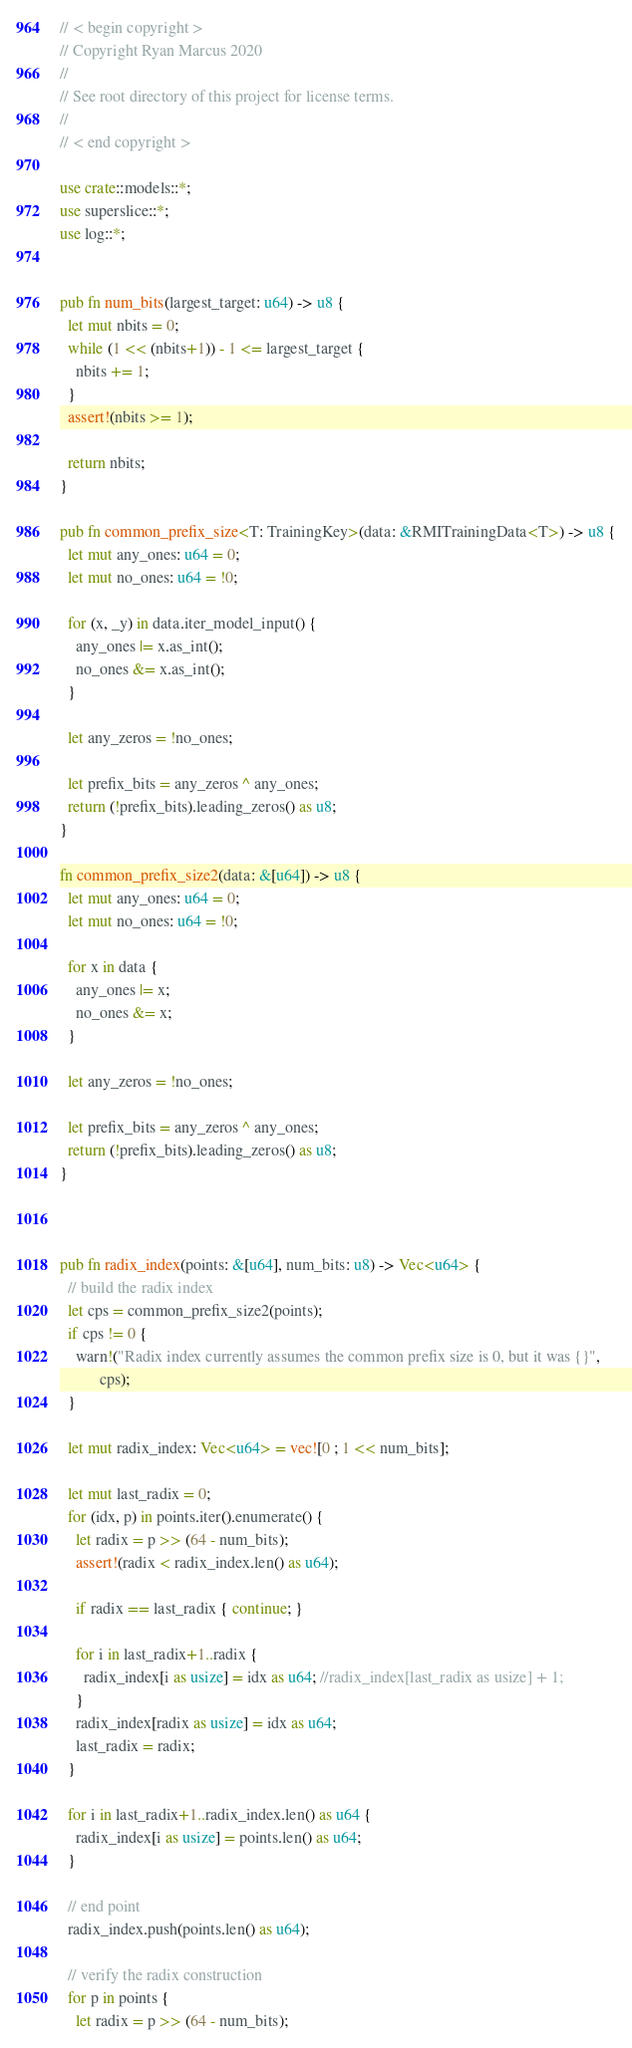<code> <loc_0><loc_0><loc_500><loc_500><_Rust_>// < begin copyright >
// Copyright Ryan Marcus 2020
//
// See root directory of this project for license terms.
//
// < end copyright >

use crate::models::*;
use superslice::*;
use log::*;


pub fn num_bits(largest_target: u64) -> u8 {
  let mut nbits = 0;
  while (1 << (nbits+1)) - 1 <= largest_target {
    nbits += 1;
  }
  assert!(nbits >= 1);

  return nbits;
}

pub fn common_prefix_size<T: TrainingKey>(data: &RMITrainingData<T>) -> u8 {
  let mut any_ones: u64 = 0;
  let mut no_ones: u64 = !0;

  for (x, _y) in data.iter_model_input() {
    any_ones |= x.as_int();
    no_ones &= x.as_int();
  }

  let any_zeros = !no_ones;

  let prefix_bits = any_zeros ^ any_ones;
  return (!prefix_bits).leading_zeros() as u8;
}

fn common_prefix_size2(data: &[u64]) -> u8 {
  let mut any_ones: u64 = 0;
  let mut no_ones: u64 = !0;

  for x in data {
    any_ones |= x;
    no_ones &= x;
  }

  let any_zeros = !no_ones;

  let prefix_bits = any_zeros ^ any_ones;
  return (!prefix_bits).leading_zeros() as u8;
}



pub fn radix_index(points: &[u64], num_bits: u8) -> Vec<u64> {
  // build the radix index
  let cps = common_prefix_size2(points);
  if cps != 0 {
    warn!("Radix index currently assumes the common prefix size is 0, but it was {}",
          cps);
  }

  let mut radix_index: Vec<u64> = vec![0 ; 1 << num_bits];

  let mut last_radix = 0;
  for (idx, p) in points.iter().enumerate() {
    let radix = p >> (64 - num_bits);
    assert!(radix < radix_index.len() as u64);

    if radix == last_radix { continue; }

    for i in last_radix+1..radix {
      radix_index[i as usize] = idx as u64; //radix_index[last_radix as usize] + 1;
    }
    radix_index[radix as usize] = idx as u64;
    last_radix = radix;
  }

  for i in last_radix+1..radix_index.len() as u64 {
    radix_index[i as usize] = points.len() as u64;
  }

  // end point
  radix_index.push(points.len() as u64);

  // verify the radix construction
  for p in points {
    let radix = p >> (64 - num_bits);</code> 